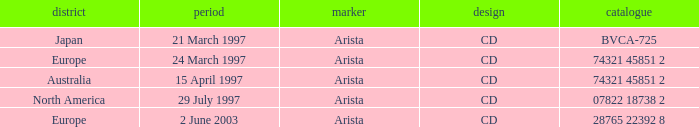What Format has the Region of Europe and a Catalog of 74321 45851 2? CD. Can you parse all the data within this table? {'header': ['district', 'period', 'marker', 'design', 'catalogue'], 'rows': [['Japan', '21 March 1997', 'Arista', 'CD', 'BVCA-725'], ['Europe', '24 March 1997', 'Arista', 'CD', '74321 45851 2'], ['Australia', '15 April 1997', 'Arista', 'CD', '74321 45851 2'], ['North America', '29 July 1997', 'Arista', 'CD', '07822 18738 2'], ['Europe', '2 June 2003', 'Arista', 'CD', '28765 22392 8']]} 